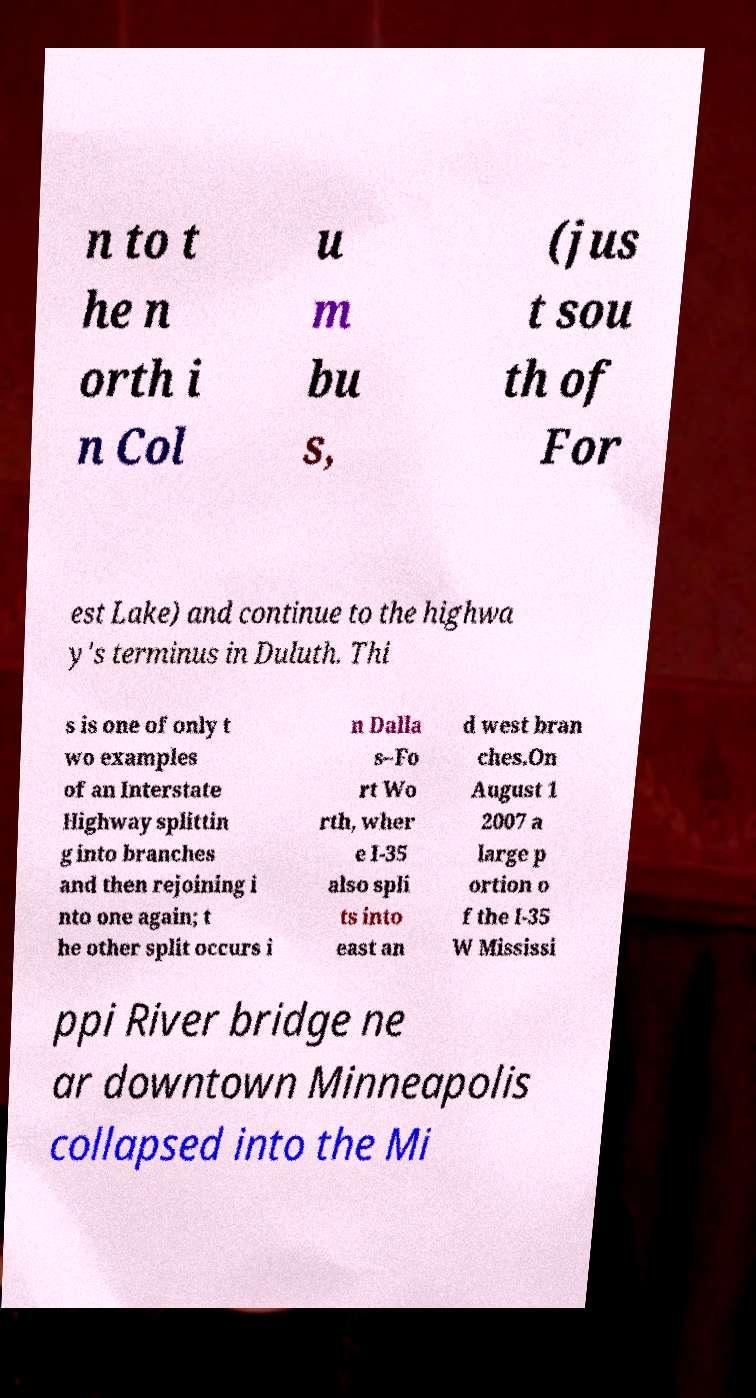Could you extract and type out the text from this image? n to t he n orth i n Col u m bu s, (jus t sou th of For est Lake) and continue to the highwa y's terminus in Duluth. Thi s is one of only t wo examples of an Interstate Highway splittin g into branches and then rejoining i nto one again; t he other split occurs i n Dalla s–Fo rt Wo rth, wher e I-35 also spli ts into east an d west bran ches.On August 1 2007 a large p ortion o f the I-35 W Mississi ppi River bridge ne ar downtown Minneapolis collapsed into the Mi 